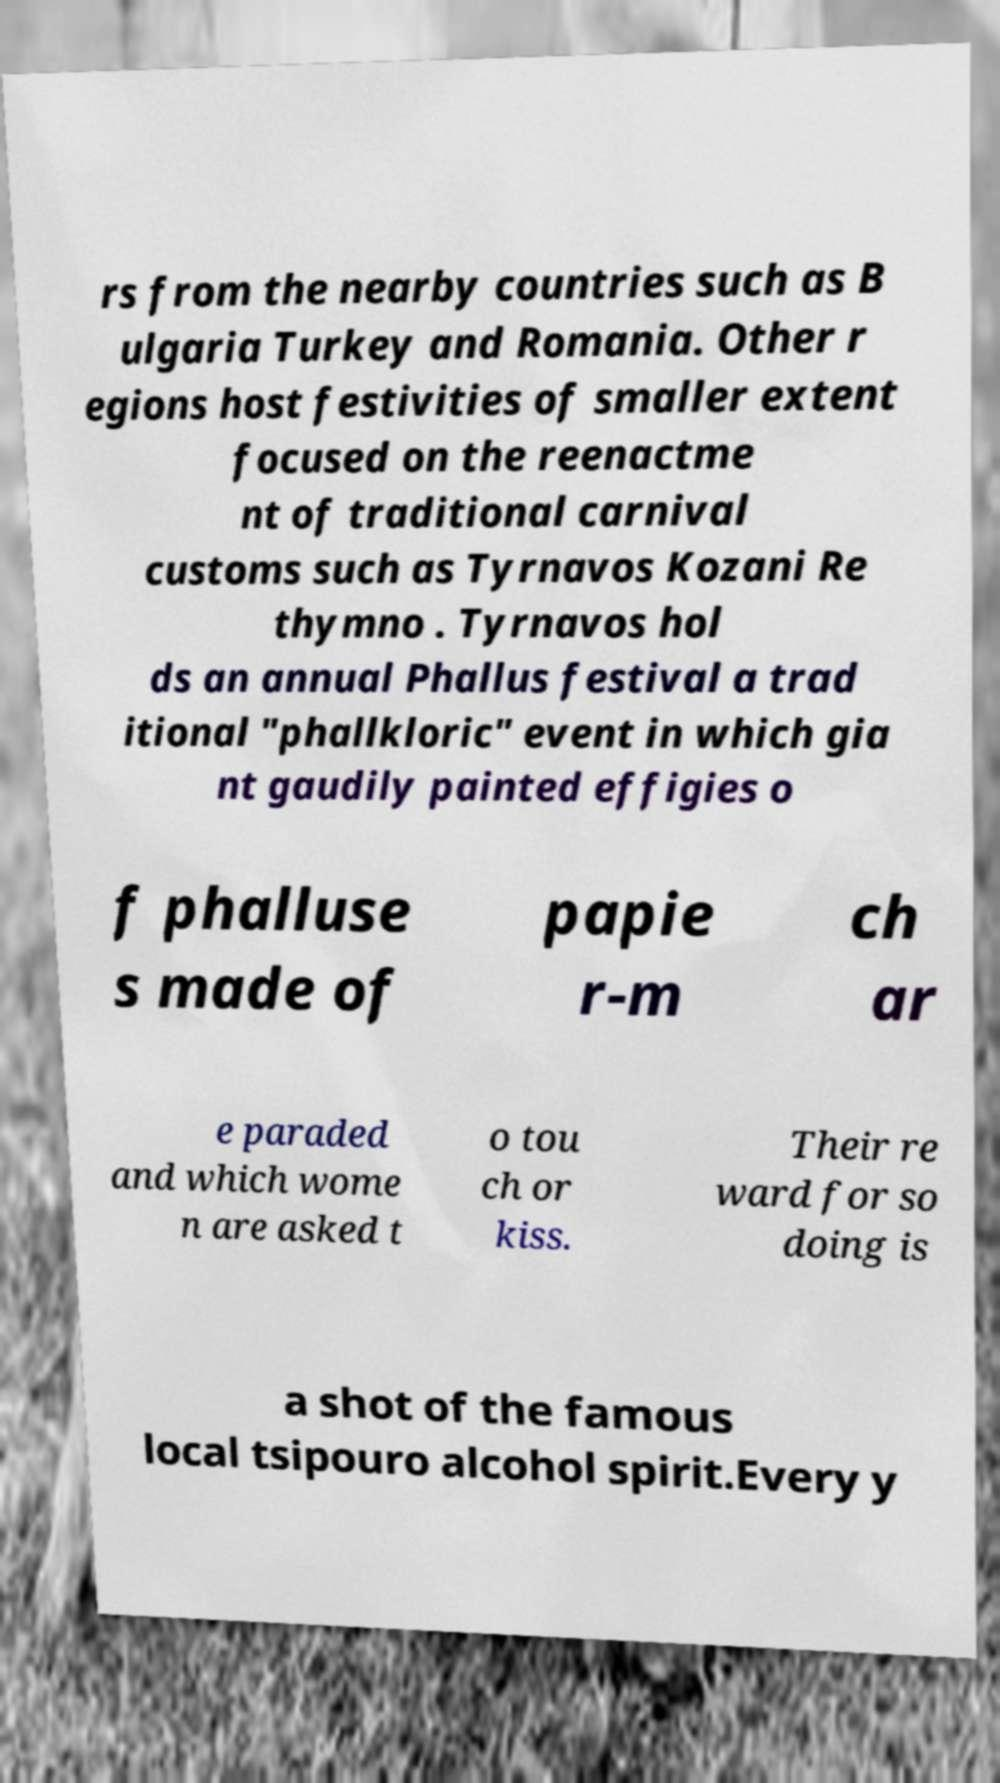Could you assist in decoding the text presented in this image and type it out clearly? rs from the nearby countries such as B ulgaria Turkey and Romania. Other r egions host festivities of smaller extent focused on the reenactme nt of traditional carnival customs such as Tyrnavos Kozani Re thymno . Tyrnavos hol ds an annual Phallus festival a trad itional "phallkloric" event in which gia nt gaudily painted effigies o f phalluse s made of papie r-m ch ar e paraded and which wome n are asked t o tou ch or kiss. Their re ward for so doing is a shot of the famous local tsipouro alcohol spirit.Every y 